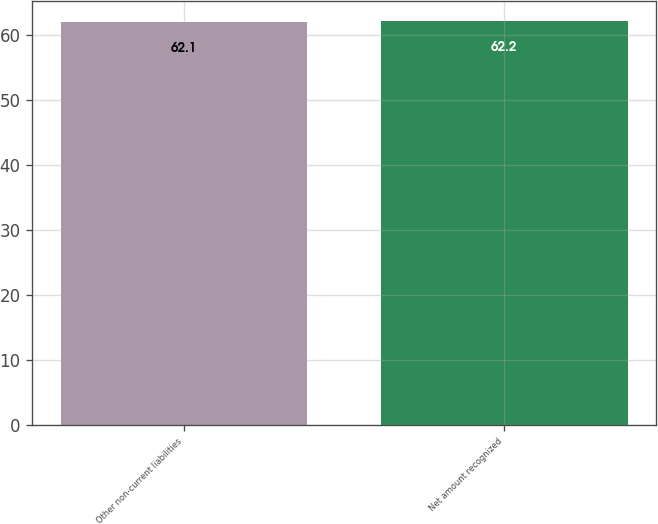Convert chart to OTSL. <chart><loc_0><loc_0><loc_500><loc_500><bar_chart><fcel>Other non-current liabilities<fcel>Net amount recognized<nl><fcel>62.1<fcel>62.2<nl></chart> 